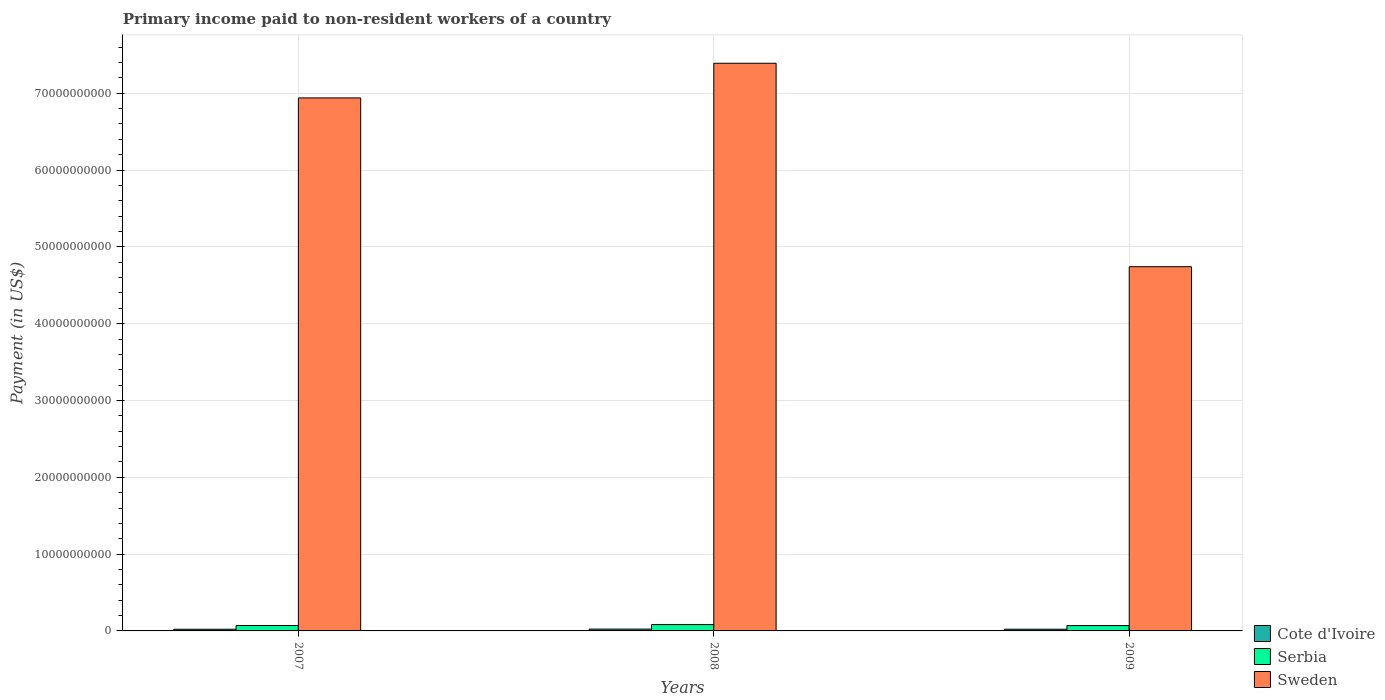How many different coloured bars are there?
Make the answer very short. 3. How many groups of bars are there?
Ensure brevity in your answer.  3. Are the number of bars per tick equal to the number of legend labels?
Your answer should be compact. Yes. What is the amount paid to workers in Sweden in 2008?
Your answer should be compact. 7.39e+1. Across all years, what is the maximum amount paid to workers in Cote d'Ivoire?
Offer a terse response. 2.37e+08. Across all years, what is the minimum amount paid to workers in Cote d'Ivoire?
Offer a very short reply. 2.18e+08. In which year was the amount paid to workers in Cote d'Ivoire minimum?
Make the answer very short. 2007. What is the total amount paid to workers in Cote d'Ivoire in the graph?
Keep it short and to the point. 6.77e+08. What is the difference between the amount paid to workers in Sweden in 2007 and that in 2008?
Make the answer very short. -4.51e+09. What is the difference between the amount paid to workers in Cote d'Ivoire in 2007 and the amount paid to workers in Sweden in 2009?
Your response must be concise. -4.72e+1. What is the average amount paid to workers in Cote d'Ivoire per year?
Provide a succinct answer. 2.26e+08. In the year 2008, what is the difference between the amount paid to workers in Cote d'Ivoire and amount paid to workers in Sweden?
Keep it short and to the point. -7.37e+1. In how many years, is the amount paid to workers in Sweden greater than 12000000000 US$?
Your answer should be very brief. 3. What is the ratio of the amount paid to workers in Sweden in 2007 to that in 2008?
Your answer should be very brief. 0.94. Is the amount paid to workers in Cote d'Ivoire in 2007 less than that in 2008?
Your answer should be very brief. Yes. What is the difference between the highest and the second highest amount paid to workers in Sweden?
Provide a short and direct response. 4.51e+09. What is the difference between the highest and the lowest amount paid to workers in Sweden?
Offer a terse response. 2.65e+1. In how many years, is the amount paid to workers in Cote d'Ivoire greater than the average amount paid to workers in Cote d'Ivoire taken over all years?
Give a very brief answer. 1. Is the sum of the amount paid to workers in Serbia in 2007 and 2009 greater than the maximum amount paid to workers in Sweden across all years?
Offer a terse response. No. What does the 1st bar from the left in 2009 represents?
Your answer should be very brief. Cote d'Ivoire. What does the 2nd bar from the right in 2007 represents?
Offer a terse response. Serbia. How many bars are there?
Make the answer very short. 9. Are all the bars in the graph horizontal?
Your answer should be very brief. No. How many years are there in the graph?
Ensure brevity in your answer.  3. Are the values on the major ticks of Y-axis written in scientific E-notation?
Keep it short and to the point. No. Does the graph contain any zero values?
Your answer should be very brief. No. Where does the legend appear in the graph?
Your answer should be very brief. Bottom right. How many legend labels are there?
Ensure brevity in your answer.  3. How are the legend labels stacked?
Provide a short and direct response. Vertical. What is the title of the graph?
Your answer should be very brief. Primary income paid to non-resident workers of a country. What is the label or title of the X-axis?
Offer a terse response. Years. What is the label or title of the Y-axis?
Your answer should be very brief. Payment (in US$). What is the Payment (in US$) of Cote d'Ivoire in 2007?
Offer a terse response. 2.18e+08. What is the Payment (in US$) in Serbia in 2007?
Make the answer very short. 7.07e+08. What is the Payment (in US$) of Sweden in 2007?
Your response must be concise. 6.94e+1. What is the Payment (in US$) in Cote d'Ivoire in 2008?
Your response must be concise. 2.37e+08. What is the Payment (in US$) of Serbia in 2008?
Give a very brief answer. 8.26e+08. What is the Payment (in US$) of Sweden in 2008?
Offer a terse response. 7.39e+1. What is the Payment (in US$) of Cote d'Ivoire in 2009?
Your response must be concise. 2.22e+08. What is the Payment (in US$) in Serbia in 2009?
Provide a short and direct response. 6.95e+08. What is the Payment (in US$) in Sweden in 2009?
Give a very brief answer. 4.74e+1. Across all years, what is the maximum Payment (in US$) in Cote d'Ivoire?
Provide a short and direct response. 2.37e+08. Across all years, what is the maximum Payment (in US$) of Serbia?
Make the answer very short. 8.26e+08. Across all years, what is the maximum Payment (in US$) of Sweden?
Ensure brevity in your answer.  7.39e+1. Across all years, what is the minimum Payment (in US$) of Cote d'Ivoire?
Provide a short and direct response. 2.18e+08. Across all years, what is the minimum Payment (in US$) of Serbia?
Provide a succinct answer. 6.95e+08. Across all years, what is the minimum Payment (in US$) in Sweden?
Your answer should be very brief. 4.74e+1. What is the total Payment (in US$) in Cote d'Ivoire in the graph?
Your response must be concise. 6.77e+08. What is the total Payment (in US$) of Serbia in the graph?
Keep it short and to the point. 2.23e+09. What is the total Payment (in US$) of Sweden in the graph?
Provide a short and direct response. 1.91e+11. What is the difference between the Payment (in US$) of Cote d'Ivoire in 2007 and that in 2008?
Provide a short and direct response. -1.85e+07. What is the difference between the Payment (in US$) in Serbia in 2007 and that in 2008?
Ensure brevity in your answer.  -1.19e+08. What is the difference between the Payment (in US$) of Sweden in 2007 and that in 2008?
Your answer should be compact. -4.51e+09. What is the difference between the Payment (in US$) of Cote d'Ivoire in 2007 and that in 2009?
Ensure brevity in your answer.  -3.83e+06. What is the difference between the Payment (in US$) in Serbia in 2007 and that in 2009?
Your response must be concise. 1.20e+07. What is the difference between the Payment (in US$) in Sweden in 2007 and that in 2009?
Provide a succinct answer. 2.20e+1. What is the difference between the Payment (in US$) of Cote d'Ivoire in 2008 and that in 2009?
Your response must be concise. 1.47e+07. What is the difference between the Payment (in US$) of Serbia in 2008 and that in 2009?
Provide a succinct answer. 1.31e+08. What is the difference between the Payment (in US$) of Sweden in 2008 and that in 2009?
Provide a succinct answer. 2.65e+1. What is the difference between the Payment (in US$) of Cote d'Ivoire in 2007 and the Payment (in US$) of Serbia in 2008?
Provide a short and direct response. -6.08e+08. What is the difference between the Payment (in US$) of Cote d'Ivoire in 2007 and the Payment (in US$) of Sweden in 2008?
Keep it short and to the point. -7.37e+1. What is the difference between the Payment (in US$) in Serbia in 2007 and the Payment (in US$) in Sweden in 2008?
Provide a succinct answer. -7.32e+1. What is the difference between the Payment (in US$) of Cote d'Ivoire in 2007 and the Payment (in US$) of Serbia in 2009?
Ensure brevity in your answer.  -4.77e+08. What is the difference between the Payment (in US$) of Cote d'Ivoire in 2007 and the Payment (in US$) of Sweden in 2009?
Give a very brief answer. -4.72e+1. What is the difference between the Payment (in US$) in Serbia in 2007 and the Payment (in US$) in Sweden in 2009?
Offer a terse response. -4.67e+1. What is the difference between the Payment (in US$) of Cote d'Ivoire in 2008 and the Payment (in US$) of Serbia in 2009?
Ensure brevity in your answer.  -4.59e+08. What is the difference between the Payment (in US$) of Cote d'Ivoire in 2008 and the Payment (in US$) of Sweden in 2009?
Your response must be concise. -4.72e+1. What is the difference between the Payment (in US$) of Serbia in 2008 and the Payment (in US$) of Sweden in 2009?
Your response must be concise. -4.66e+1. What is the average Payment (in US$) of Cote d'Ivoire per year?
Your response must be concise. 2.26e+08. What is the average Payment (in US$) of Serbia per year?
Make the answer very short. 7.43e+08. What is the average Payment (in US$) of Sweden per year?
Offer a terse response. 6.36e+1. In the year 2007, what is the difference between the Payment (in US$) in Cote d'Ivoire and Payment (in US$) in Serbia?
Your answer should be very brief. -4.89e+08. In the year 2007, what is the difference between the Payment (in US$) in Cote d'Ivoire and Payment (in US$) in Sweden?
Give a very brief answer. -6.92e+1. In the year 2007, what is the difference between the Payment (in US$) in Serbia and Payment (in US$) in Sweden?
Ensure brevity in your answer.  -6.87e+1. In the year 2008, what is the difference between the Payment (in US$) in Cote d'Ivoire and Payment (in US$) in Serbia?
Your response must be concise. -5.90e+08. In the year 2008, what is the difference between the Payment (in US$) of Cote d'Ivoire and Payment (in US$) of Sweden?
Keep it short and to the point. -7.37e+1. In the year 2008, what is the difference between the Payment (in US$) in Serbia and Payment (in US$) in Sweden?
Your answer should be very brief. -7.31e+1. In the year 2009, what is the difference between the Payment (in US$) in Cote d'Ivoire and Payment (in US$) in Serbia?
Your response must be concise. -4.73e+08. In the year 2009, what is the difference between the Payment (in US$) in Cote d'Ivoire and Payment (in US$) in Sweden?
Provide a short and direct response. -4.72e+1. In the year 2009, what is the difference between the Payment (in US$) in Serbia and Payment (in US$) in Sweden?
Provide a succinct answer. -4.67e+1. What is the ratio of the Payment (in US$) in Cote d'Ivoire in 2007 to that in 2008?
Your answer should be compact. 0.92. What is the ratio of the Payment (in US$) of Serbia in 2007 to that in 2008?
Make the answer very short. 0.86. What is the ratio of the Payment (in US$) of Sweden in 2007 to that in 2008?
Offer a terse response. 0.94. What is the ratio of the Payment (in US$) of Cote d'Ivoire in 2007 to that in 2009?
Your answer should be compact. 0.98. What is the ratio of the Payment (in US$) of Serbia in 2007 to that in 2009?
Provide a succinct answer. 1.02. What is the ratio of the Payment (in US$) in Sweden in 2007 to that in 2009?
Ensure brevity in your answer.  1.46. What is the ratio of the Payment (in US$) of Cote d'Ivoire in 2008 to that in 2009?
Provide a succinct answer. 1.07. What is the ratio of the Payment (in US$) in Serbia in 2008 to that in 2009?
Provide a succinct answer. 1.19. What is the ratio of the Payment (in US$) of Sweden in 2008 to that in 2009?
Provide a short and direct response. 1.56. What is the difference between the highest and the second highest Payment (in US$) in Cote d'Ivoire?
Provide a succinct answer. 1.47e+07. What is the difference between the highest and the second highest Payment (in US$) of Serbia?
Keep it short and to the point. 1.19e+08. What is the difference between the highest and the second highest Payment (in US$) of Sweden?
Keep it short and to the point. 4.51e+09. What is the difference between the highest and the lowest Payment (in US$) of Cote d'Ivoire?
Offer a very short reply. 1.85e+07. What is the difference between the highest and the lowest Payment (in US$) in Serbia?
Ensure brevity in your answer.  1.31e+08. What is the difference between the highest and the lowest Payment (in US$) of Sweden?
Keep it short and to the point. 2.65e+1. 